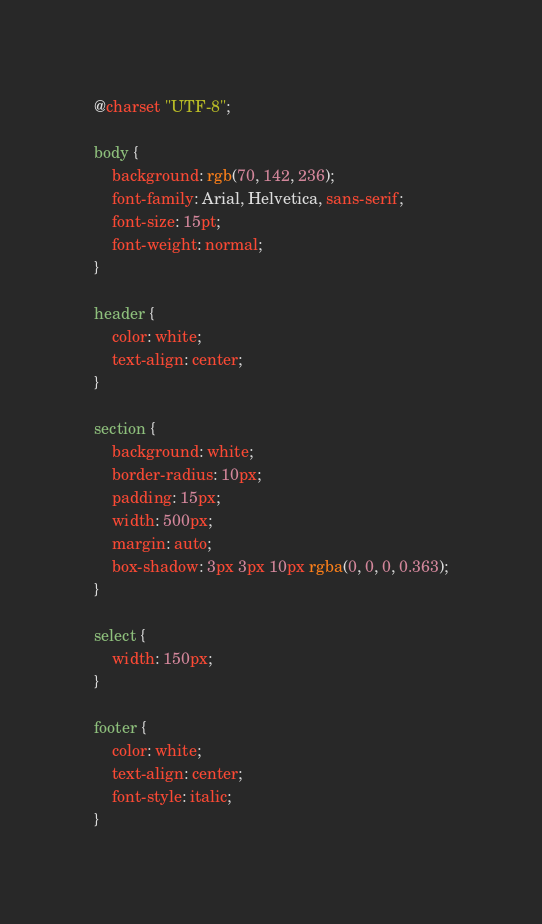Convert code to text. <code><loc_0><loc_0><loc_500><loc_500><_CSS_>@charset "UTF-8";

body {
    background: rgb(70, 142, 236);
    font-family: Arial, Helvetica, sans-serif;
    font-size: 15pt;
    font-weight: normal;
}

header {
    color: white;
    text-align: center;
}

section {
    background: white;
    border-radius: 10px;
    padding: 15px;
    width: 500px;
    margin: auto;
    box-shadow: 3px 3px 10px rgba(0, 0, 0, 0.363);
}

select {
    width: 150px;
}

footer {
    color: white;
    text-align: center;
    font-style: italic;
}</code> 